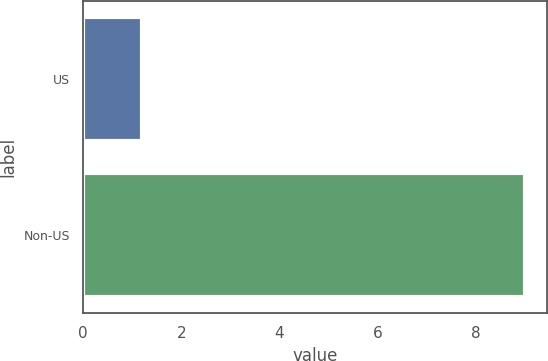<chart> <loc_0><loc_0><loc_500><loc_500><bar_chart><fcel>US<fcel>Non-US<nl><fcel>1.2<fcel>9<nl></chart> 